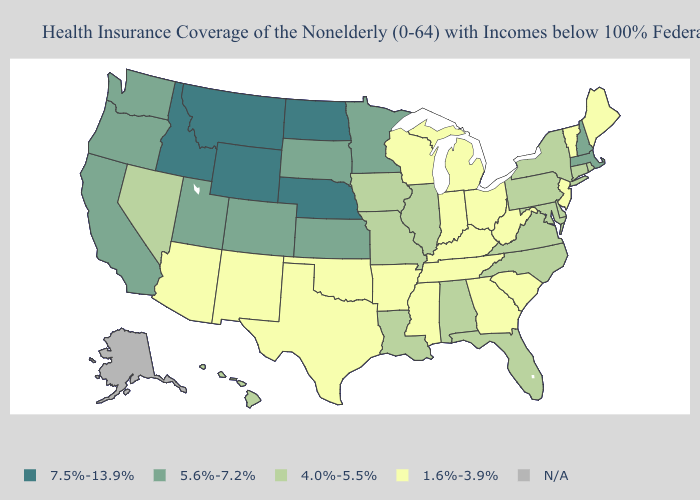Name the states that have a value in the range 7.5%-13.9%?
Concise answer only. Idaho, Montana, Nebraska, North Dakota, Wyoming. Does Pennsylvania have the lowest value in the Northeast?
Keep it brief. No. Among the states that border Colorado , does Oklahoma have the lowest value?
Be succinct. Yes. Which states have the highest value in the USA?
Keep it brief. Idaho, Montana, Nebraska, North Dakota, Wyoming. What is the value of Missouri?
Keep it brief. 4.0%-5.5%. What is the value of Wisconsin?
Short answer required. 1.6%-3.9%. What is the value of Montana?
Keep it brief. 7.5%-13.9%. How many symbols are there in the legend?
Write a very short answer. 5. What is the value of Texas?
Be succinct. 1.6%-3.9%. Which states have the lowest value in the USA?
Be succinct. Arizona, Arkansas, Georgia, Indiana, Kentucky, Maine, Michigan, Mississippi, New Jersey, New Mexico, Ohio, Oklahoma, South Carolina, Tennessee, Texas, Vermont, West Virginia, Wisconsin. Among the states that border Florida , does Alabama have the lowest value?
Keep it brief. No. Name the states that have a value in the range 5.6%-7.2%?
Give a very brief answer. California, Colorado, Kansas, Massachusetts, Minnesota, New Hampshire, Oregon, South Dakota, Utah, Washington. How many symbols are there in the legend?
Be succinct. 5. What is the value of North Carolina?
Concise answer only. 4.0%-5.5%. 